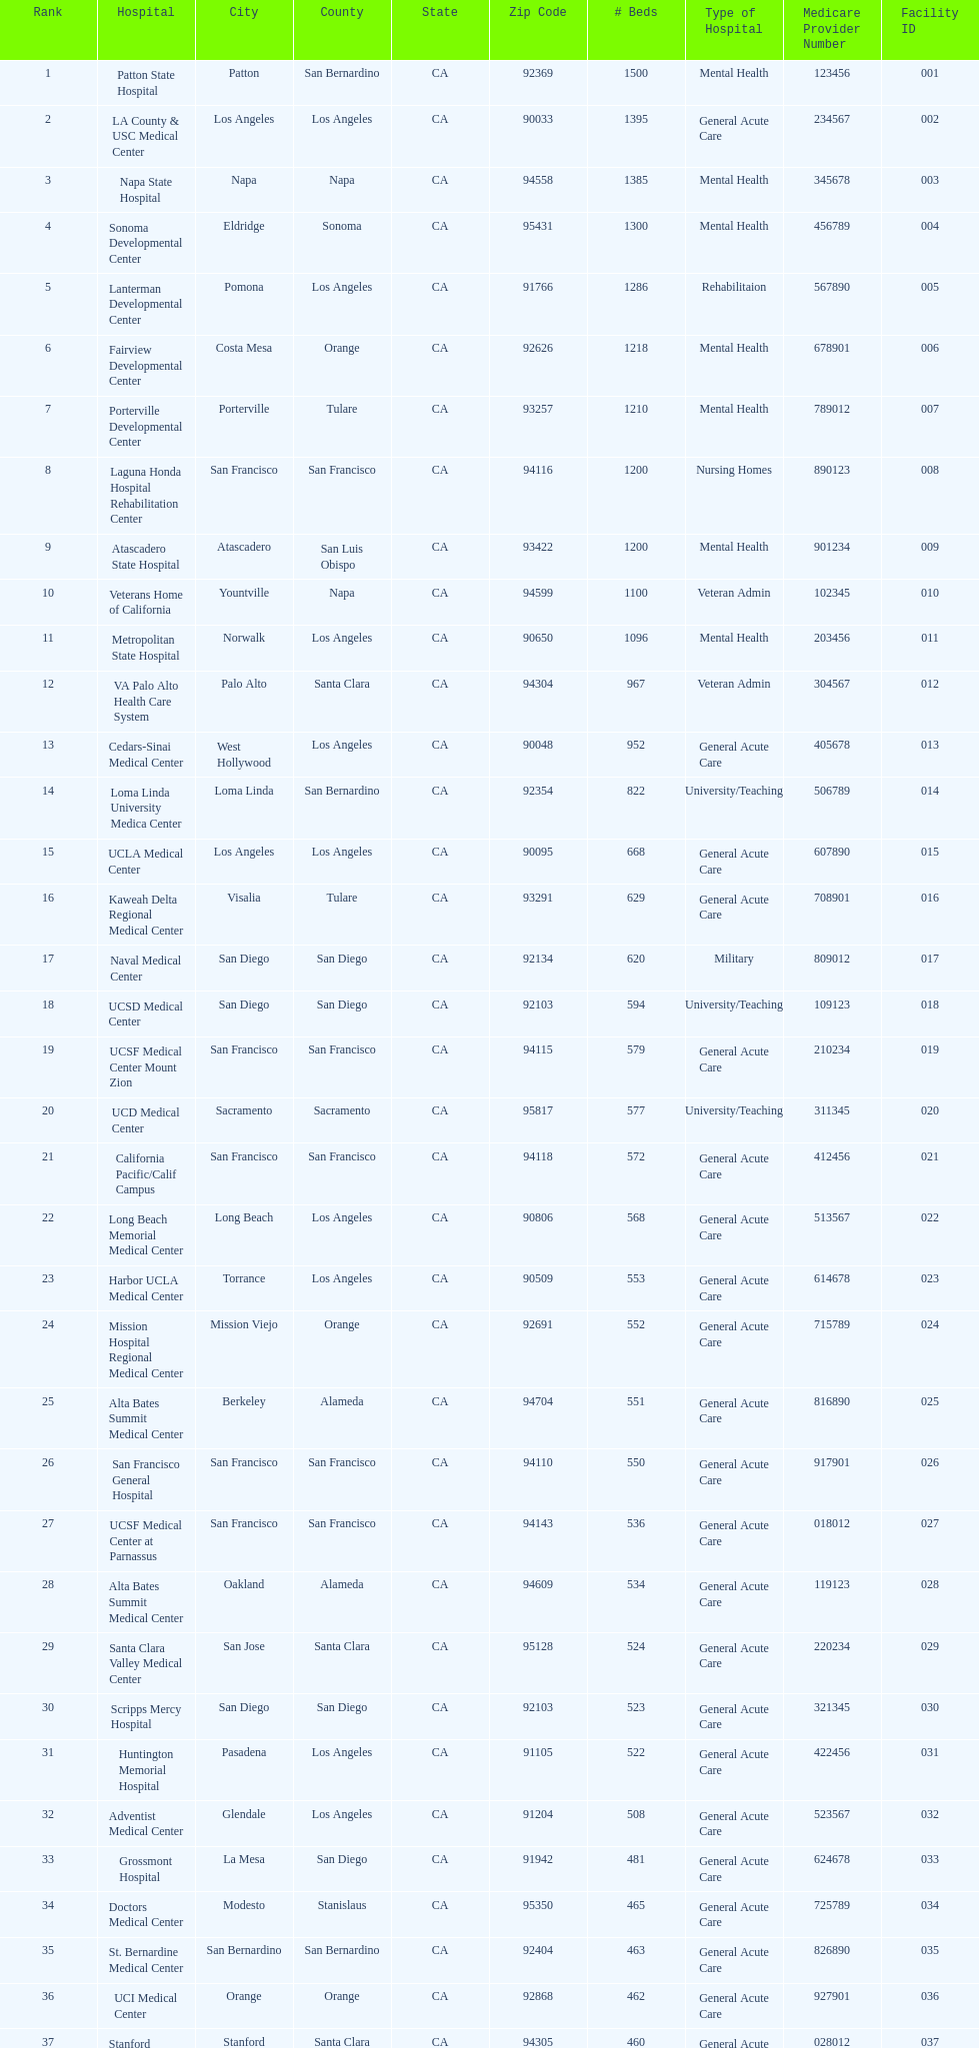Would you be able to parse every entry in this table? {'header': ['Rank', 'Hospital', 'City', 'County', 'State', 'Zip Code', '# Beds', 'Type of Hospital', 'Medicare Provider Number', 'Facility ID'], 'rows': [['1', 'Patton State Hospital', 'Patton', 'San Bernardino', 'CA', '92369', '1500', 'Mental Health', '123456', '001'], ['2', 'LA County & USC Medical Center', 'Los Angeles', 'Los Angeles', 'CA', '90033', '1395', 'General Acute Care', '234567', '002'], ['3', 'Napa State Hospital', 'Napa', 'Napa', 'CA', '94558', '1385', 'Mental Health', '345678', '003'], ['4', 'Sonoma Developmental Center', 'Eldridge', 'Sonoma', 'CA', '95431', '1300', 'Mental Health', '456789', '004'], ['5', 'Lanterman Developmental Center', 'Pomona', 'Los Angeles', 'CA', '91766', '1286', 'Rehabilitaion', '567890', '005'], ['6', 'Fairview Developmental Center', 'Costa Mesa', 'Orange', 'CA', '92626', '1218', 'Mental Health', '678901', '006'], ['7', 'Porterville Developmental Center', 'Porterville', 'Tulare', 'CA', '93257', '1210', 'Mental Health', '789012', '007'], ['8', 'Laguna Honda Hospital Rehabilitation Center', 'San Francisco', 'San Francisco', 'CA', '94116', '1200', 'Nursing Homes', '890123', '008'], ['9', 'Atascadero State Hospital', 'Atascadero', 'San Luis Obispo', 'CA', '93422', '1200', 'Mental Health', '901234', '009'], ['10', 'Veterans Home of California', 'Yountville', 'Napa', 'CA', '94599', '1100', 'Veteran Admin', '102345', '010'], ['11', 'Metropolitan State Hospital', 'Norwalk', 'Los Angeles', 'CA', '90650', '1096', 'Mental Health', '203456', '011'], ['12', 'VA Palo Alto Health Care System', 'Palo Alto', 'Santa Clara', 'CA', '94304', '967', 'Veteran Admin', '304567', '012'], ['13', 'Cedars-Sinai Medical Center', 'West Hollywood', 'Los Angeles', 'CA', '90048', '952', 'General Acute Care', '405678', '013'], ['14', 'Loma Linda University Medica Center', 'Loma Linda', 'San Bernardino', 'CA', '92354', '822', 'University/Teaching', '506789', '014'], ['15', 'UCLA Medical Center', 'Los Angeles', 'Los Angeles', 'CA', '90095', '668', 'General Acute Care', '607890', '015'], ['16', 'Kaweah Delta Regional Medical Center', 'Visalia', 'Tulare', 'CA', '93291', '629', 'General Acute Care', '708901', '016'], ['17', 'Naval Medical Center', 'San Diego', 'San Diego', 'CA', '92134', '620', 'Military', '809012', '017'], ['18', 'UCSD Medical Center', 'San Diego', 'San Diego', 'CA', '92103', '594', 'University/Teaching', '109123', '018'], ['19', 'UCSF Medical Center Mount Zion', 'San Francisco', 'San Francisco', 'CA', '94115', '579', 'General Acute Care', '210234', '019'], ['20', 'UCD Medical Center', 'Sacramento', 'Sacramento', 'CA', '95817', '577', 'University/Teaching', '311345', '020'], ['21', 'California Pacific/Calif Campus', 'San Francisco', 'San Francisco', 'CA', '94118', '572', 'General Acute Care', '412456', '021'], ['22', 'Long Beach Memorial Medical Center', 'Long Beach', 'Los Angeles', 'CA', '90806', '568', 'General Acute Care', '513567', '022'], ['23', 'Harbor UCLA Medical Center', 'Torrance', 'Los Angeles', 'CA', '90509', '553', 'General Acute Care', '614678', '023'], ['24', 'Mission Hospital Regional Medical Center', 'Mission Viejo', 'Orange', 'CA', '92691', '552', 'General Acute Care', '715789', '024'], ['25', 'Alta Bates Summit Medical Center', 'Berkeley', 'Alameda', 'CA', '94704', '551', 'General Acute Care', '816890', '025'], ['26', 'San Francisco General Hospital', 'San Francisco', 'San Francisco', 'CA', '94110', '550', 'General Acute Care', '917901', '026'], ['27', 'UCSF Medical Center at Parnassus', 'San Francisco', 'San Francisco', 'CA', '94143', '536', 'General Acute Care', '018012', '027'], ['28', 'Alta Bates Summit Medical Center', 'Oakland', 'Alameda', 'CA', '94609', '534', 'General Acute Care', '119123', '028'], ['29', 'Santa Clara Valley Medical Center', 'San Jose', 'Santa Clara', 'CA', '95128', '524', 'General Acute Care', '220234', '029'], ['30', 'Scripps Mercy Hospital', 'San Diego', 'San Diego', 'CA', '92103', '523', 'General Acute Care', '321345', '030'], ['31', 'Huntington Memorial Hospital', 'Pasadena', 'Los Angeles', 'CA', '91105', '522', 'General Acute Care', '422456', '031'], ['32', 'Adventist Medical Center', 'Glendale', 'Los Angeles', 'CA', '91204', '508', 'General Acute Care', '523567', '032'], ['33', 'Grossmont Hospital', 'La Mesa', 'San Diego', 'CA', '91942', '481', 'General Acute Care', '624678', '033'], ['34', 'Doctors Medical Center', 'Modesto', 'Stanislaus', 'CA', '95350', '465', 'General Acute Care', '725789', '034'], ['35', 'St. Bernardine Medical Center', 'San Bernardino', 'San Bernardino', 'CA', '92404', '463', 'General Acute Care', '826890', '035'], ['36', 'UCI Medical Center', 'Orange', 'Orange', 'CA', '92868', '462', 'General Acute Care', '927901', '036'], ['37', 'Stanford Medical Center', 'Stanford', 'Santa Clara', 'CA', '94305', '460', 'General Acute Care', '028012', '037'], ['38', 'Community Regional Medical Center', 'Fresno', 'Fresno', 'CA', '93721', '457', 'General Acute Care', '129123', '038'], ['39', 'Methodist Hospital', 'Arcadia', 'Los Angeles', 'CA', '91007', '455', 'General Acute Care', '230234', '039'], ['40', 'Providence St. Joseph Medical Center', 'Burbank', 'Los Angeles', 'CA', '91505', '455', 'General Acute Care', '331345', '040'], ['41', 'Hoag Memorial Hospital', 'Newport Beach', 'Orange', 'CA', '92663', '450', 'General Acute Care', '432456', '041'], ['42', 'Agnews Developmental Center', 'San Jose', 'Santa Clara', 'CA', '95134', '450', 'Mental Health', '533567', '042'], ['43', 'Jewish Home', 'San Francisco', 'San Francisco', 'CA', '94112', '450', 'Nursing Homes', '634678', '043'], ['44', 'St. Joseph Hospital Orange', 'Orange', 'Orange', 'CA', '92868', '448', 'General Acute Care', '735789', '044'], ['45', 'Presbyterian Intercommunity', 'Whittier', 'Los Angeles', 'CA', '90602', '441', 'General Acute Care', '836890', '045'], ['46', 'Kaiser Permanente Medical Center', 'Fontana', 'San Bernardino', 'CA', '92335', '440', 'General Acute Care', '937901', '046'], ['47', 'Kaiser Permanente Medical Center', 'Los Angeles', 'Los Angeles', 'CA', '90027', '439', 'General Acute Care', '038012', '047'], ['48', 'Pomona Valley Hospital Medical Center', 'Pomona', 'Los Angeles', 'CA', '91767', '436', 'General Acute Care', '139123', '048'], ['49', 'Sutter General Medical Center', 'Sacramento', 'Sacramento', 'CA', '95819', '432', 'General Acute Care', '240234', '049'], ['50', 'St. Mary Medical Center', 'San Francisco', 'San Francisco', 'CA', '94114', '430', 'General Acute Care', '341345', '050'], ['50', 'Good Samaritan Hospital', 'San Jose', 'Santa Clara', 'CA', '95124', '429', 'General Acute Care', '442456', '051']]} Does patton state hospital in the city of patton in san bernardino county have more mental health hospital beds than atascadero state hospital in atascadero, san luis obispo county? Yes. 